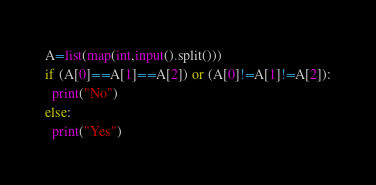Convert code to text. <code><loc_0><loc_0><loc_500><loc_500><_Python_>A=list(map(int,input().split()))
if (A[0]==A[1]==A[2]) or (A[0]!=A[1]!=A[2]):
  print("No")
else:
  print("Yes")</code> 